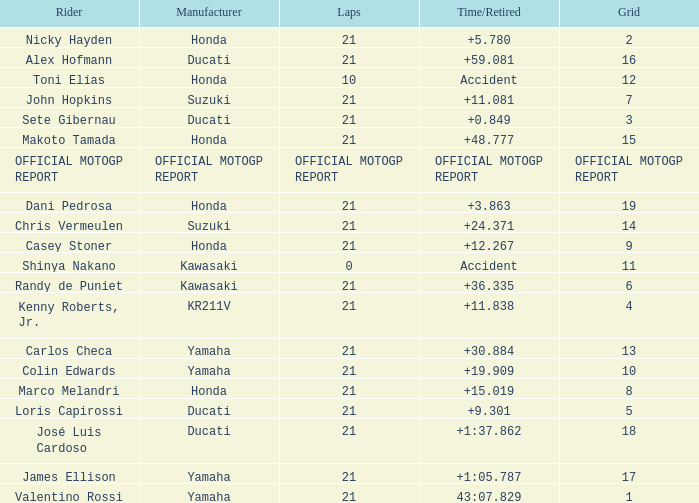Which rider had a time/retired od +19.909? Colin Edwards. 